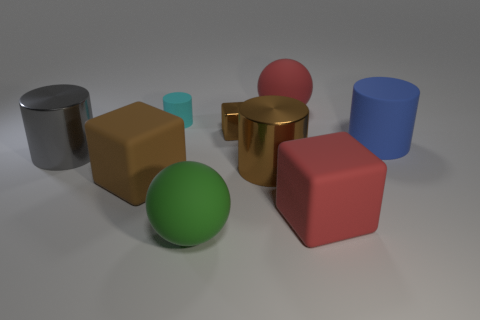There is a matte sphere behind the small rubber object; is its color the same as the tiny rubber cylinder that is to the left of the red matte sphere?
Your answer should be very brief. No. What is the shape of the large rubber thing that is right of the red thing in front of the big metal thing that is right of the tiny shiny object?
Make the answer very short. Cylinder. What is the shape of the big rubber thing that is both behind the large brown shiny thing and in front of the big red sphere?
Keep it short and to the point. Cylinder. What number of rubber objects are behind the large red thing that is in front of the red matte thing behind the big brown cube?
Keep it short and to the point. 4. What is the size of the red rubber thing that is the same shape as the big brown matte thing?
Your answer should be very brief. Large. Are there any other things that are the same size as the blue matte object?
Your answer should be compact. Yes. Is the material of the brown block to the right of the large green matte sphere the same as the big blue thing?
Provide a short and direct response. No. What color is the tiny thing that is the same shape as the big blue object?
Provide a short and direct response. Cyan. How many other objects are there of the same color as the small rubber thing?
Keep it short and to the point. 0. Does the shiny object that is to the left of the small shiny object have the same shape as the brown shiny object in front of the big gray metal cylinder?
Ensure brevity in your answer.  Yes. 